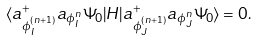<formula> <loc_0><loc_0><loc_500><loc_500>\langle a _ { \phi ^ { ( n + 1 ) } _ { I } } ^ { + } a _ { \phi ^ { n } _ { I } } \Psi _ { 0 } | H | a _ { \phi ^ { ( n + 1 ) } _ { J } } ^ { + } a _ { \phi ^ { n } _ { J } } \Psi _ { 0 } \rangle = 0 .</formula> 